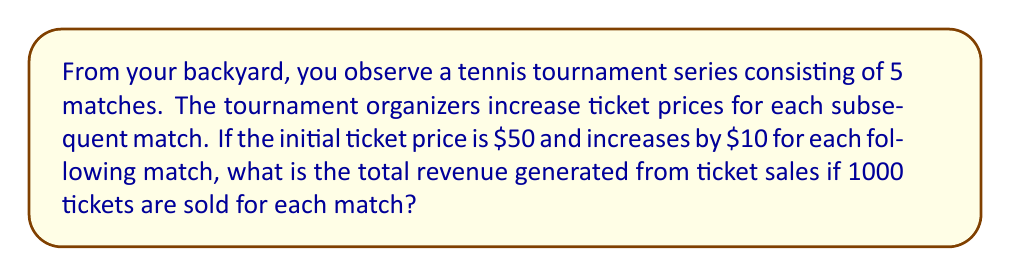Help me with this question. Let's approach this step-by-step:

1) First, let's identify the ticket prices for each match:
   Match 1: $50
   Match 2: $60
   Match 3: $70
   Match 4: $80
   Match 5: $90

2) This forms an arithmetic sequence with:
   First term, $a_1 = 50$
   Common difference, $d = 10$
   Number of terms, $n = 5$

3) To find the total revenue, we need to sum these prices and multiply by the number of tickets sold per match.

4) The sum of an arithmetic sequence is given by the formula:
   $$S_n = \frac{n}{2}(a_1 + a_n)$$
   where $a_n$ is the last term.

5) We can calculate $a_n$ using the arithmetic sequence formula:
   $$a_n = a_1 + (n-1)d = 50 + (5-1)10 = 90$$

6) Now, let's apply the sum formula:
   $$S_5 = \frac{5}{2}(50 + 90) = \frac{5}{2}(140) = 350$$

7) This $350 represents the sum of ticket prices for one set of tickets across all matches.

8) Since 1000 tickets are sold for each match, we multiply this sum by 1000:
   $$\text{Total Revenue} = 350 \times 1000 = 350,000$$

Therefore, the total revenue generated from ticket sales is $350,000.
Answer: $350,000 